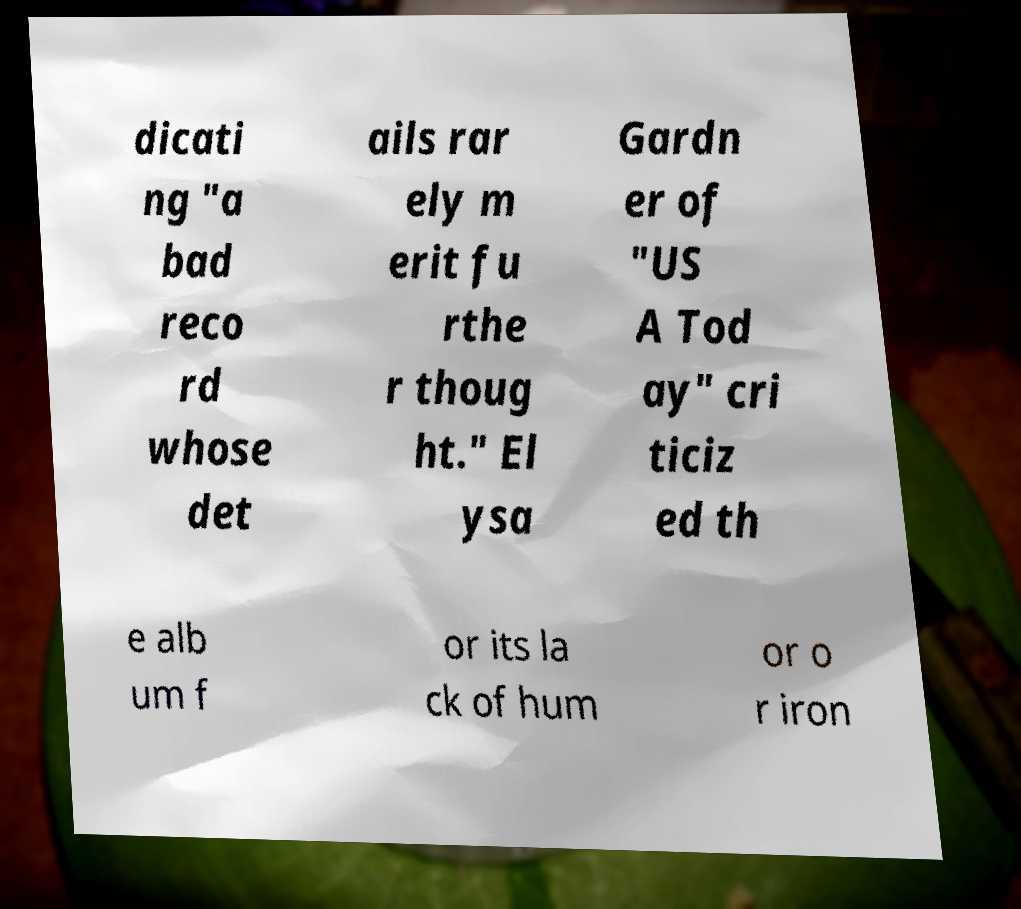Can you read and provide the text displayed in the image?This photo seems to have some interesting text. Can you extract and type it out for me? dicati ng "a bad reco rd whose det ails rar ely m erit fu rthe r thoug ht." El ysa Gardn er of "US A Tod ay" cri ticiz ed th e alb um f or its la ck of hum or o r iron 